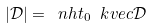<formula> <loc_0><loc_0><loc_500><loc_500>| \mathcal { D } | = \ n h t _ { 0 } \ k v e c \mathcal { D }</formula> 